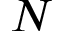Convert formula to latex. <formula><loc_0><loc_0><loc_500><loc_500>N</formula> 